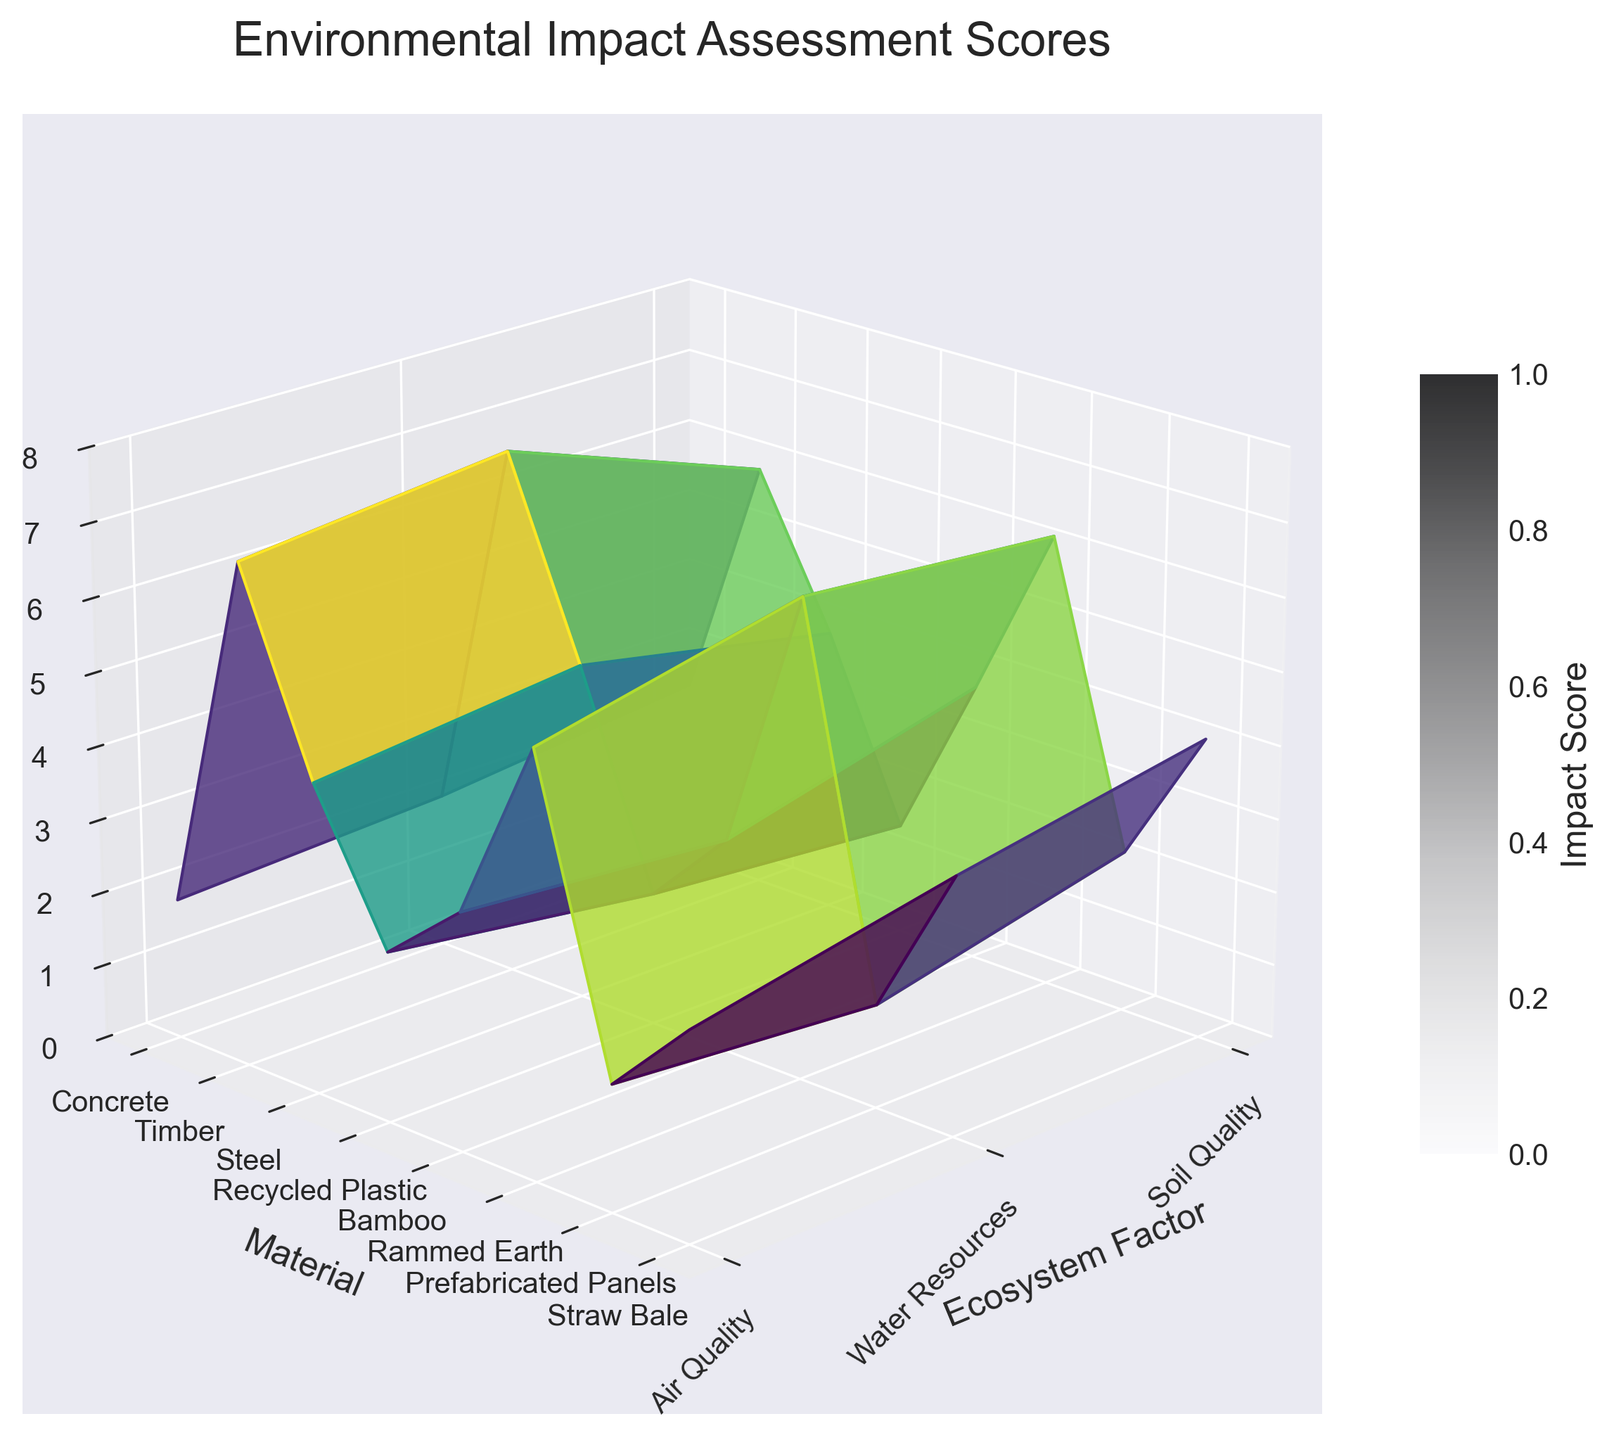What is the title of the figure? The title of the figure is displayed at the top of the plot in a larger font. It provides a brief description of what the plot represents, summarizing the data presented.
Answer: Environmental Impact Assessment Scores Which material has the lowest impact score on soil quality? To determine the material with the lowest impact score on soil quality, locate the "Soil Quality" axis and find the minimum value. Then, match this value to the corresponding material on the "Material" axis.
Answer: Straw Bale How does Bamboo compare with Timber in terms of water resources impact? To compare Bamboo and Timber regarding their impact on water resources, locate both materials on the "Material" axis and the corresponding impact scores on the "Water Resources" axis. Compare the values to see which is higher or lower.
Answer: Bamboo has a lower impact score than Timber What is the range of impact scores for air quality across all materials? To find the range of impact scores for air quality, identify the minimum and maximum impact scores for air quality across all materials. Subtract the minimum from the maximum to get the range.
Answer: 5.9 - 1.5 = 4.4 Which material has the highest overall impact score for any ecosystem factor? To determine which material has the highest overall impact score, examine the maximum values for all three ecosystem factors for each material, and identify the highest value. Then record the material associated with this value.
Answer: Concrete What is the average impact score for Recycled Plastic across all ecosystem factors? Calculate the average impact score for Recycled Plastic by summing its impact scores for Soil Quality (2.9), Water Resources (3.2), and Air Quality (3.8), then divide by 3.
Answer: (2.9 + 3.2 + 3.8) / 3 ≈ 3.3 Between Rammed Earth and Prefabricated Panels, which one has a lesser impact on Air Quality? Compare the impact scores for Air Quality for both Rammed Earth and Prefabricated Panels by locating these values on the plot. Determine which score is lower.
Answer: Rammed Earth What is the total impact score for Straw Bale across all ecosystem factors? To find the total impact score for Straw Bale, sum its impact scores for Soil Quality (1.4), Water Resources (1.7), and Air Quality (2.2).
Answer: 1.4 + 1.7 + 2.2 = 5.3 Which ecosystem factor has the highest average impact score across all materials? Calculate the average impact scores for Soil Quality, Water Resources, and Air Quality across all materials. Compare these averages to determine which ecosystem factor has the highest average.
Answer: Soil Quality What is the impact score difference between Concrete and Steel in terms of Soil Quality? Find the impact scores for Soil Quality for both Concrete and Steel by locating these values on the plot. Subtract Steel's score from Concrete's score to get the difference.
Answer: 7.2 - 6.5 = 0.7 